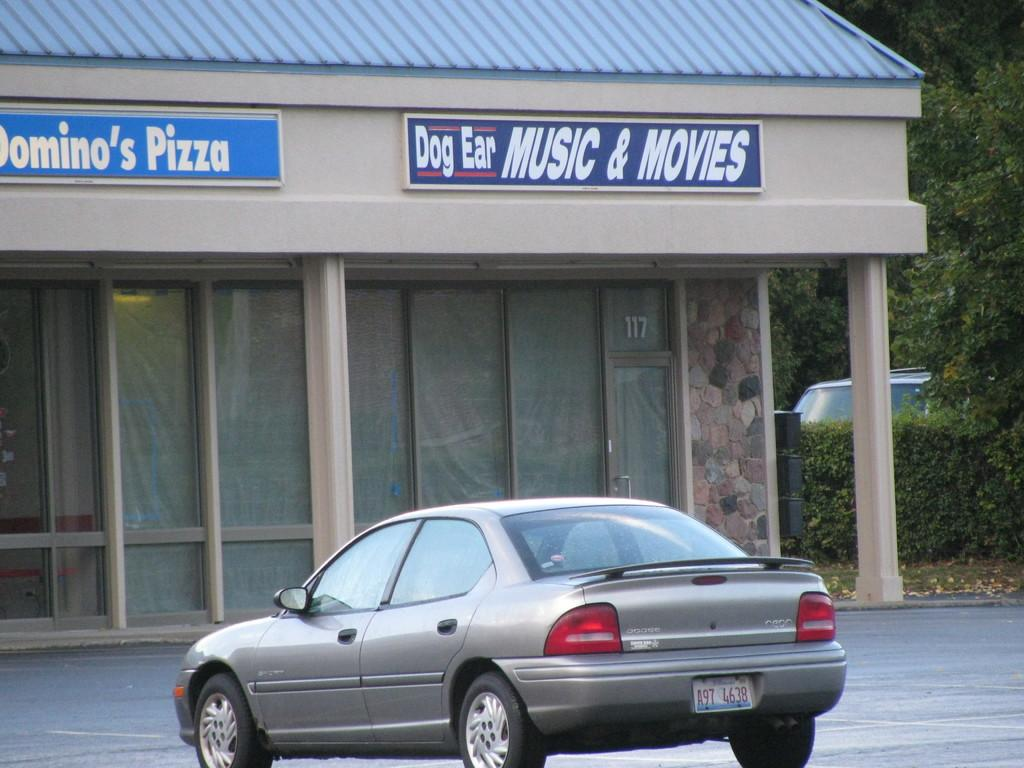What is the main subject of the image? There is a vehicle on the road in the image. What is in front of the vehicle? There is a building with some boards in front of the vehicle. What can be seen around the building? There are trees around the building. What type of punishment is being handed out in the image? There is no indication of any punishment being handed out in the image. What date is shown on the calendar in the image? There is no calendar present in the image. 